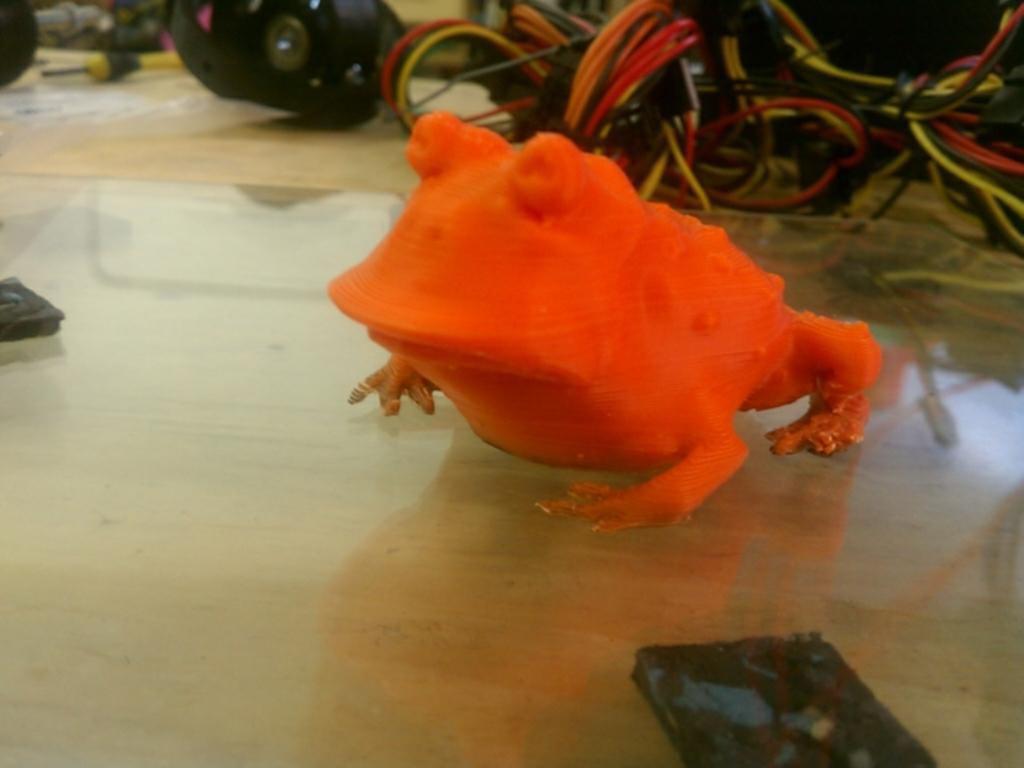How would you summarize this image in a sentence or two? In this image I can see an orange color frog on the floor. In the background, I can see the wires. 